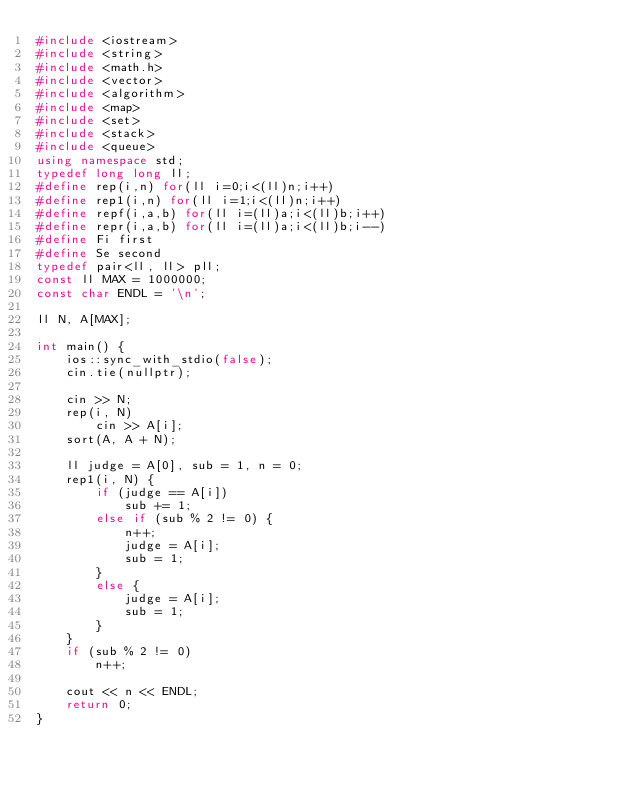Convert code to text. <code><loc_0><loc_0><loc_500><loc_500><_C++_>#include <iostream>
#include <string>
#include <math.h>
#include <vector>
#include <algorithm>
#include <map>
#include <set>
#include <stack>
#include <queue>
using namespace std;
typedef long long ll;
#define rep(i,n) for(ll i=0;i<(ll)n;i++)
#define rep1(i,n) for(ll i=1;i<(ll)n;i++)
#define repf(i,a,b) for(ll i=(ll)a;i<(ll)b;i++)
#define repr(i,a,b) for(ll i=(ll)a;i<(ll)b;i--)
#define Fi first
#define Se second
typedef pair<ll, ll> pll;
const ll MAX = 1000000;
const char ENDL = '\n';

ll N, A[MAX];

int main() {
	ios::sync_with_stdio(false);
	cin.tie(nullptr);

	cin >> N;
	rep(i, N)
		cin >> A[i];
	sort(A, A + N);

	ll judge = A[0], sub = 1, n = 0;
	rep1(i, N) {
		if (judge == A[i])
			sub += 1;
		else if (sub % 2 != 0) {
			n++;
			judge = A[i];
			sub = 1;
		}
		else {
			judge = A[i];
			sub = 1;
		}			
	}
	if (sub % 2 != 0)
		n++;

	cout << n << ENDL;
	return 0;
}</code> 